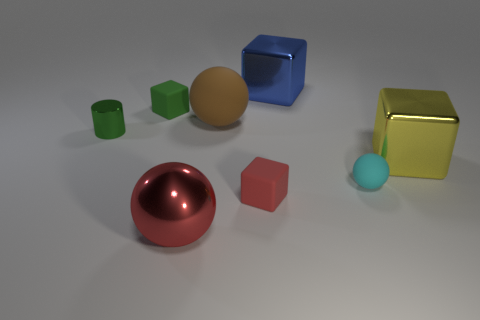The cylinder is what color?
Keep it short and to the point. Green. The big shiny object to the left of the large blue shiny cube is what color?
Ensure brevity in your answer.  Red. There is a big shiny ball that is in front of the red rubber thing; how many small balls are in front of it?
Offer a terse response. 0. There is a red rubber block; is its size the same as the object that is behind the tiny green matte object?
Your answer should be compact. No. Is there a red ball that has the same size as the red cube?
Give a very brief answer. No. What number of objects are big blue rubber cubes or small cyan objects?
Your answer should be compact. 1. There is a blue block that is behind the green matte block; is its size the same as the matte cube behind the small red matte cube?
Your response must be concise. No. Is there a large purple metal thing that has the same shape as the tiny green metallic object?
Provide a short and direct response. No. Is the number of big yellow metallic objects that are behind the tiny green rubber block less than the number of tiny gray rubber cylinders?
Provide a short and direct response. No. Is the shape of the brown matte object the same as the green matte thing?
Provide a short and direct response. No. 